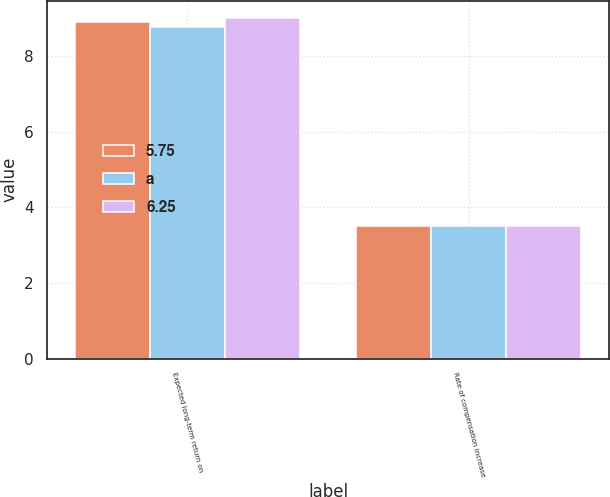Convert chart. <chart><loc_0><loc_0><loc_500><loc_500><stacked_bar_chart><ecel><fcel>Expected long-term return on<fcel>Rate of compensation increase<nl><fcel>5.75<fcel>8.9<fcel>3.5<nl><fcel>a<fcel>8.75<fcel>3.5<nl><fcel>6.25<fcel>9<fcel>3.5<nl></chart> 